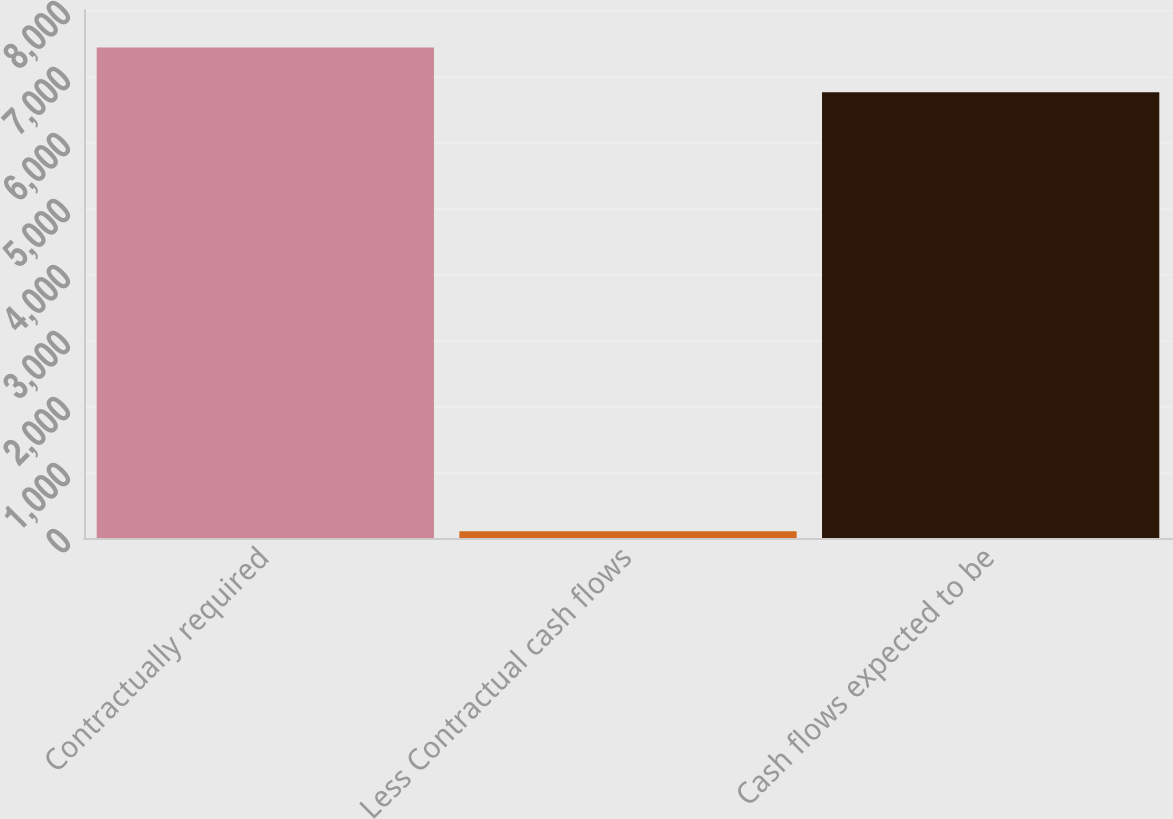Convert chart. <chart><loc_0><loc_0><loc_500><loc_500><bar_chart><fcel>Contractually required<fcel>Less Contractual cash flows<fcel>Cash flows expected to be<nl><fcel>7430.5<fcel>102<fcel>6755<nl></chart> 